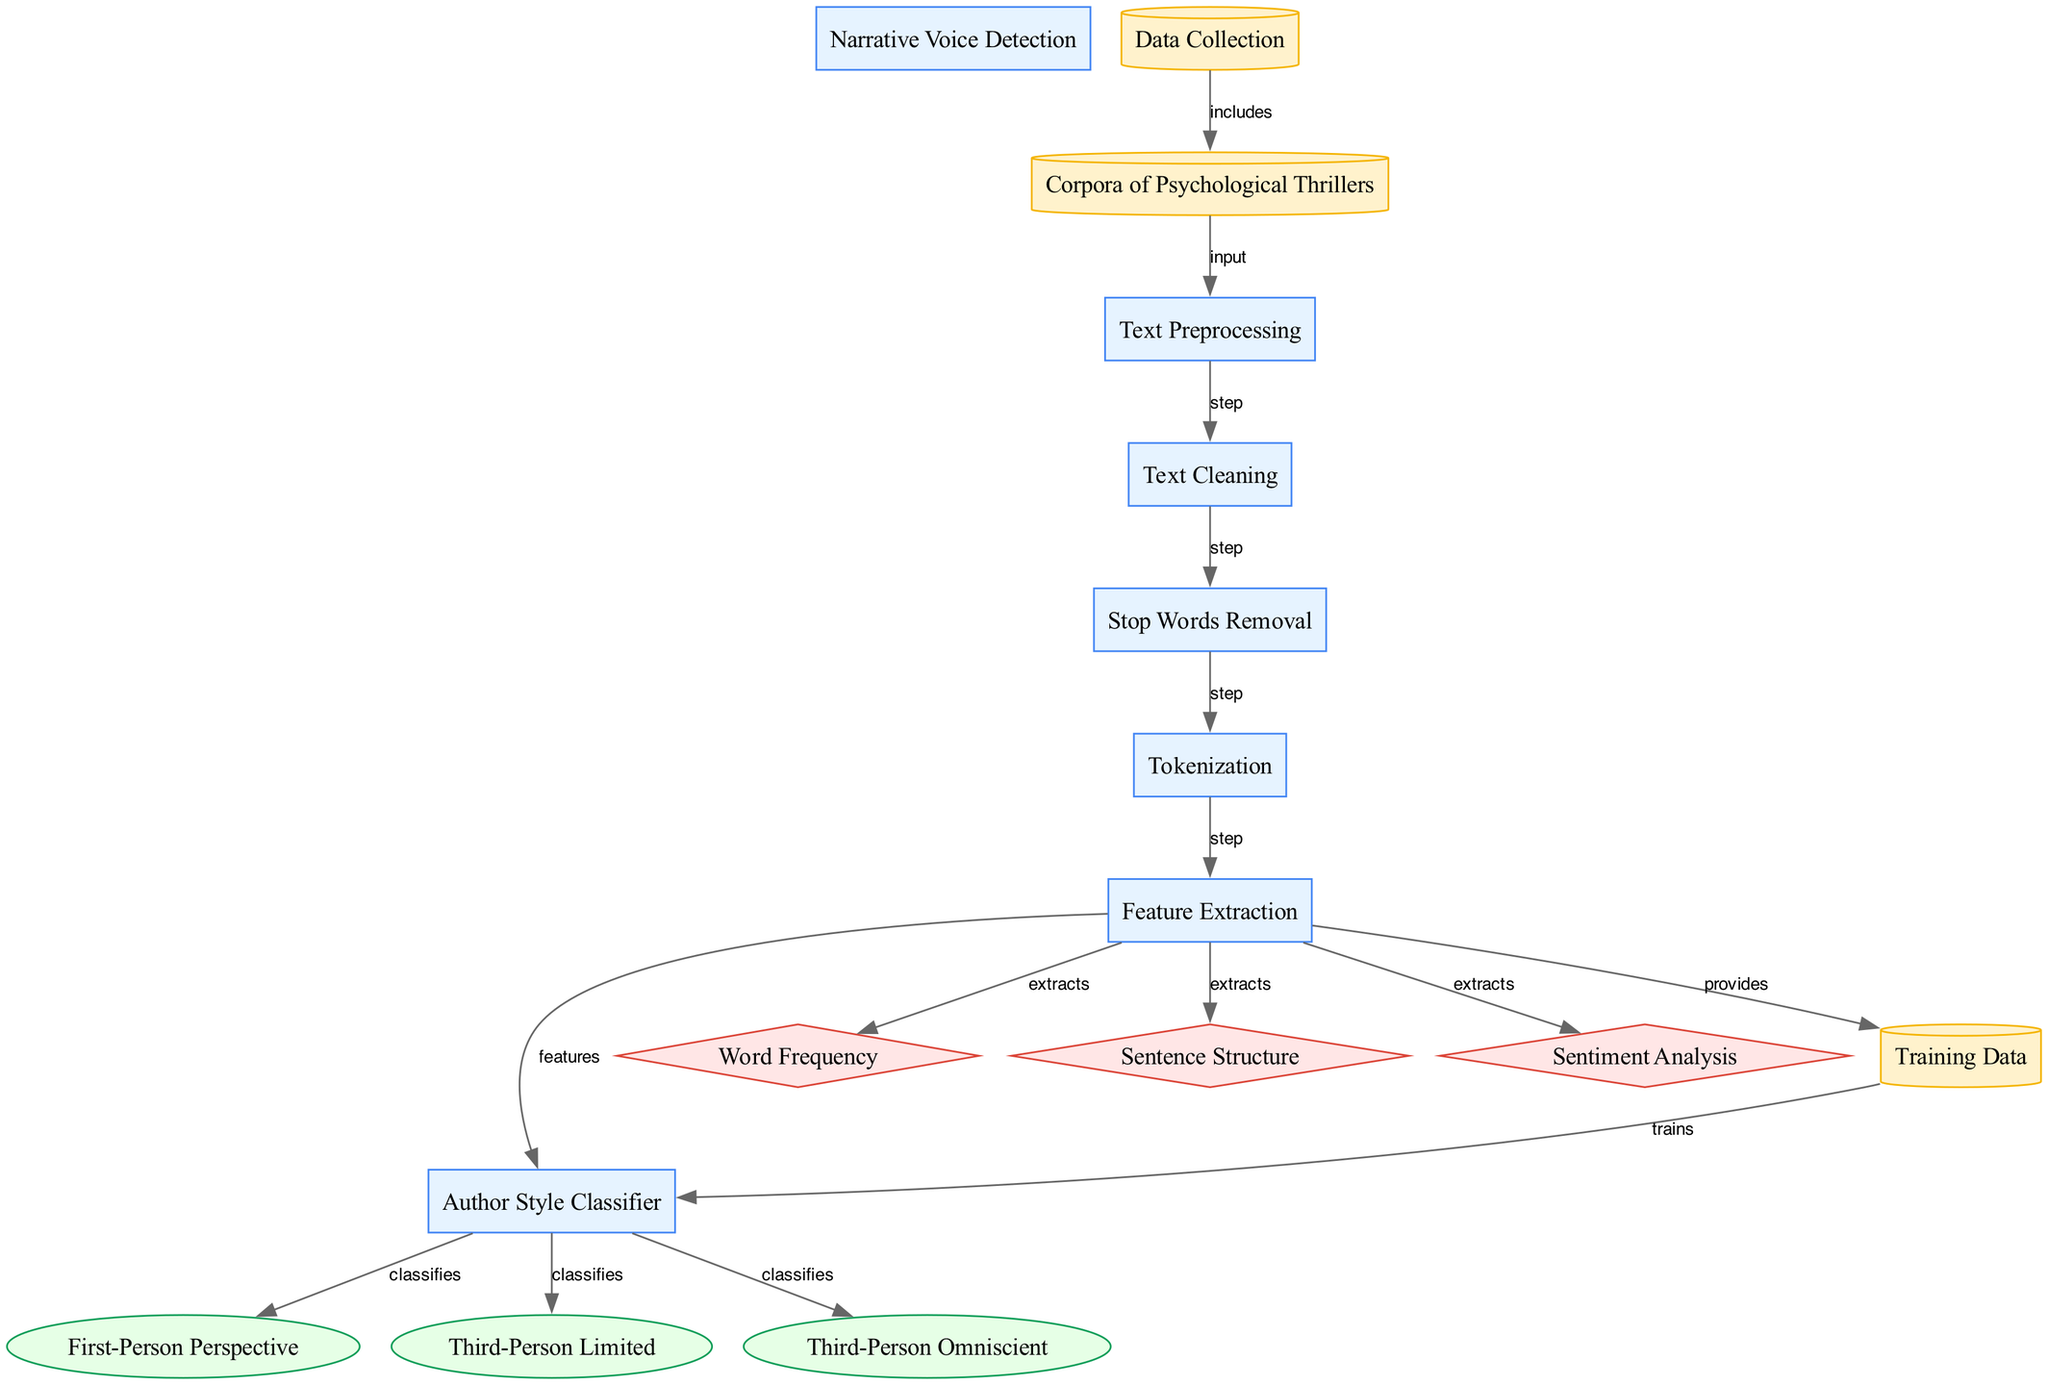What is the starting point of the process in this diagram? The starting point of the process is the "Data Collection" node, which initiates the workflow leading to narrative voice classification.
Answer: Data Collection How many output types does the diagram classify? The diagram classifies three output types: "First-Person Perspective," "Third-Person Limited," and "Third-Person Omniscient."
Answer: Three What is the immediate process that follows "Text Preprocessing"? The immediate process that follows "Text Preprocessing" is "Text Cleaning," which is crucial for preparing the text before further steps.
Answer: Text Cleaning Which process extracts features like "Word Frequency"? The process that extracts "Word Frequency" is "Feature Extraction," as indicated by the edges connecting it to various features.
Answer: Feature Extraction What is the relationship between "Training Data" and "Author Style Classifier"? The "Training Data" is used to train the "Author Style Classifier," allowing it to perform classifications based on learned features.
Answer: Trains What feature is not associated with "Feature Extraction"? Among the features, all are associated except for "Data Collection," which is an initial input rather than a feature of the text.
Answer: Data Collection Which process comes directly after "Stop Words Removal"? "Tokenization" comes directly after "Stop Words Removal," indicating a sequence of operations to prepare the text for analysis.
Answer: Tokenization What type of process is "Narrative Voice Detection"? "Narrative Voice Detection" is a process type, it is the overall objective of the diagram focusing on classifying narrative styles.
Answer: Process 